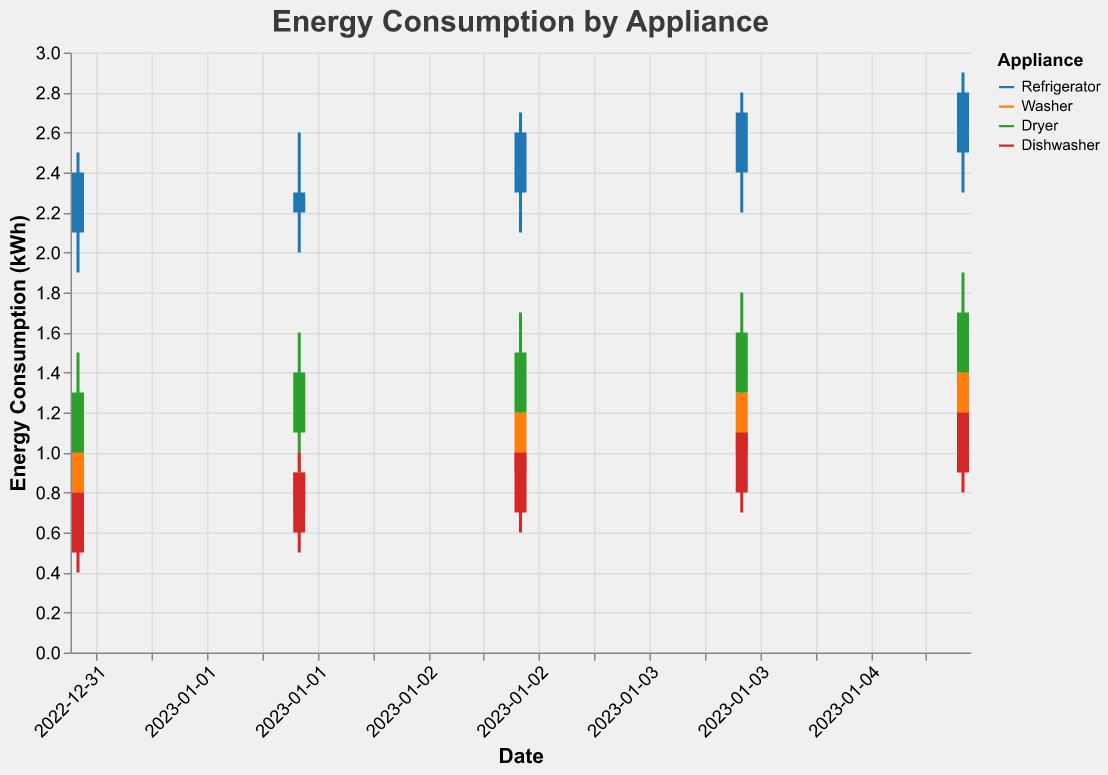What is the title of the figure? The title is displayed at the top of the figure, which provides an overview of the figure's content. By reading the title, we can understand that it visualizes energy consumption.
Answer: Energy Consumption by Appliance Which appliance had the highest peak energy consumption on January 1st, 2023? By observing the highest points on January 1st for each appliance, the "Dryer" reached the highest peak of 1.5 kWh.
Answer: Dryer During which date did the washer have the lowest energy consumption? To find the lowest energy consumption for the washer, we look for the smallest "Low" value in the washer's candlestick data. The washer had its lowest consumption at 0.6 kWh on January 2nd.
Answer: January 2nd Did the refrigerator's energy consumption always close higher than it opened? If not, when did it close lower? By comparing the "Open" and "Close" values for the refrigerator across all dates, we find that on January 2nd, the refrigerator closed at 2.3 kWh, which is lower than its opening value of 2.2 kWh.
Answer: January 2nd Which appliance saw the most consistent increase in its closing energy consumption over the five days? Checking the "Close" values for each appliance over the days, only the "Refrigerator" consistently increased its closing values from 2.4 to 2.8 kWh across January 1st to 5th.
Answer: Refrigerator Which day had the highest increase in energy consumption for the dryer from its opening to its closing value? By calculating the differences between "Close" and "Open" values for the dryer on each day, January 4th shows the largest increase with 1.6 - 1.3 = 0.3 kWh.
Answer: January 4th On which day did the dishwasher have the smallest difference between its highest and lowest energy consumption? By comparing the differences between "High" and "Low" values for the dishwasher, January 1st shows the smallest difference with 0.9 - 0.4 = 0.5 kWh.
Answer: January 1st Which appliance displayed the least variation in its high energy consumption values over the five days? The variation can be measured by checking the consistency of "High" values. The dishwasher's high values fluctuate between 0.9 and 1.3 kWh, showing the least variation compared to others.
Answer: Dishwasher Comparing the washer and dryer, which appliance had a larger sum of closing energy consumption from January 1st to January 5th? Adding up "Close" values for the washer (1.1 + 0.9 + 1.2 + 1.3 + 1.4 = 5.9 kWh) and the dryer (1.3 + 1.4 + 1.5 + 1.6 + 1.7 = 7.5 kWh), the dryer had a larger sum.
Answer: Dryer 